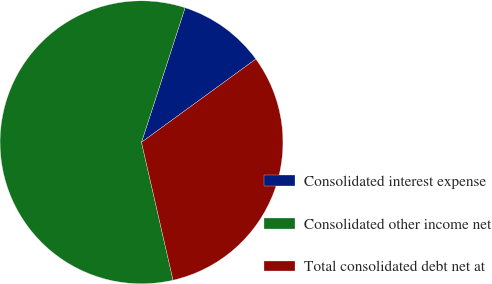Convert chart. <chart><loc_0><loc_0><loc_500><loc_500><pie_chart><fcel>Consolidated interest expense<fcel>Consolidated other income net<fcel>Total consolidated debt net at<nl><fcel>10.0%<fcel>58.57%<fcel>31.43%<nl></chart> 